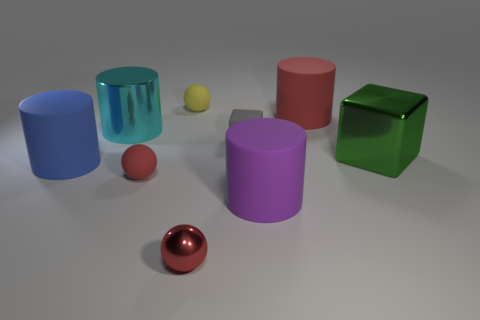Subtract 1 cylinders. How many cylinders are left? 3 Subtract all red cylinders. Subtract all green blocks. How many cylinders are left? 3 Add 1 small blocks. How many objects exist? 10 Subtract all cylinders. How many objects are left? 5 Subtract 1 yellow balls. How many objects are left? 8 Subtract all red cylinders. Subtract all big green cubes. How many objects are left? 7 Add 5 small yellow rubber objects. How many small yellow rubber objects are left? 6 Add 5 yellow rubber things. How many yellow rubber things exist? 6 